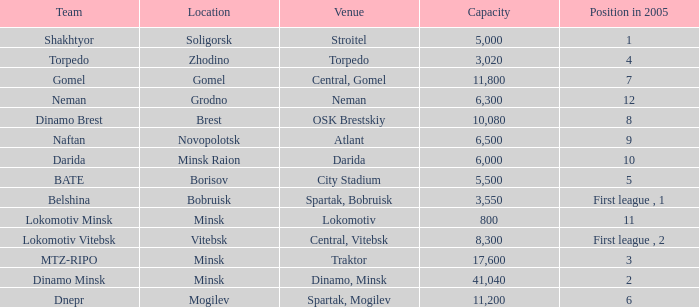Can you give me this table as a dict? {'header': ['Team', 'Location', 'Venue', 'Capacity', 'Position in 2005'], 'rows': [['Shakhtyor', 'Soligorsk', 'Stroitel', '5,000', '1'], ['Torpedo', 'Zhodino', 'Torpedo', '3,020', '4'], ['Gomel', 'Gomel', 'Central, Gomel', '11,800', '7'], ['Neman', 'Grodno', 'Neman', '6,300', '12'], ['Dinamo Brest', 'Brest', 'OSK Brestskiy', '10,080', '8'], ['Naftan', 'Novopolotsk', 'Atlant', '6,500', '9'], ['Darida', 'Minsk Raion', 'Darida', '6,000', '10'], ['BATE', 'Borisov', 'City Stadium', '5,500', '5'], ['Belshina', 'Bobruisk', 'Spartak, Bobruisk', '3,550', 'First league , 1'], ['Lokomotiv Minsk', 'Minsk', 'Lokomotiv', '800', '11'], ['Lokomotiv Vitebsk', 'Vitebsk', 'Central, Vitebsk', '8,300', 'First league , 2'], ['MTZ-RIPO', 'Minsk', 'Traktor', '17,600', '3'], ['Dinamo Minsk', 'Minsk', 'Dinamo, Minsk', '41,040', '2'], ['Dnepr', 'Mogilev', 'Spartak, Mogilev', '11,200', '6']]} What is the largest capacity held by the team of torpedo? 3020.0. 